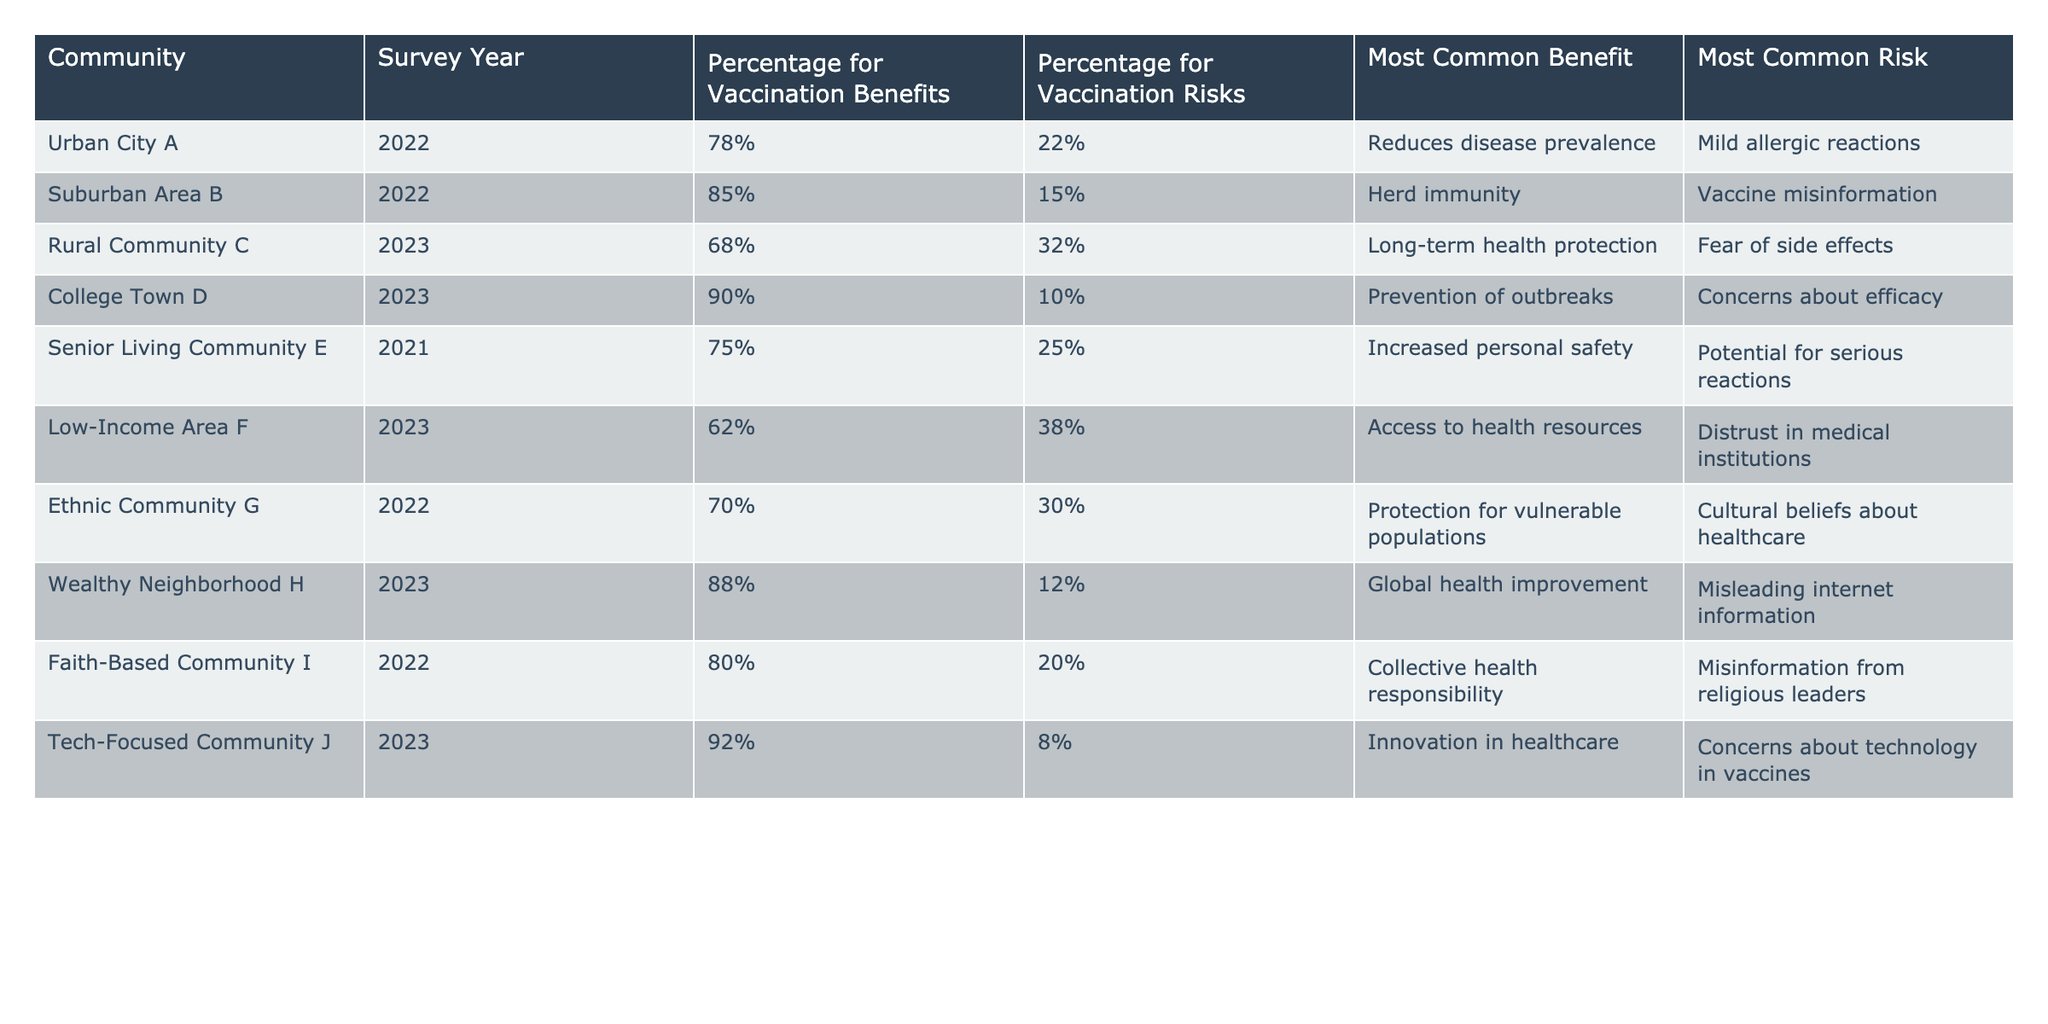What percentage of respondents in Rural Community C believe in vaccination benefits? Referring to the table, the percentage for vaccination benefits in Rural Community C is listed as 68%.
Answer: 68% Which community had the highest percentage of belief in vaccination benefits? The table shows that College Town D has the highest percentage for vaccination benefits at 90%.
Answer: 90% What is the most common risk mentioned by respondents in Low-Income Area F? According to the table, the most common risk in Low-Income Area F is "Distrust in medical institutions."
Answer: Distrust in medical institutions How many communities had a percentage for vaccination risks of 30% or above? Based on the table, the communities with 30% or above for vaccination risks are Rural Community C (32%), Low-Income Area F (38%), Ethnic Community G (30%), and Senior Living Community E (25%). This totals 4 communities.
Answer: 4 Is there a community where the most common benefit relates to healthcare innovation? The table shows that Tech-Focused Community J lists the most common benefit as "Innovation in healthcare." Therefore, the answer is yes.
Answer: Yes What is the average percentage of belief in vaccination benefits across all communities? The percentages are: 78, 85, 68, 90, 75, 62, 70, 88, 80, and 92. The sum is 828 and dividing by 10 gives an average of 82.8%.
Answer: 82.8% Which community has the least concern about vaccination risks? The percentage for vaccination risks is lowest in Tech-Focused Community J, which has only 8%.
Answer: 8% What common benefit is shared by both Suburban Area B and Wealthy Neighborhood H? Both Suburban Area B and Wealthy Neighborhood H list "Herd immunity" and "Global health improvement," respectively, which relate to improving overall community health, but no identical terms. The answer is no common benefit.
Answer: No common benefit Are respondents in Faith-Based Community I more concerned about misinformation from religious leaders or mild allergic reactions? The table indicates that the most common risk for Faith-Based Community I is "Misinformation from religious leaders," which implies this is viewed as a greater concern than mild allergic reactions stated elsewhere.
Answer: Misinformation from religious leaders What is the percentage difference in belief regarding vaccination benefits between College Town D and Low-Income Area F? College Town D has 90% for vaccination benefits while Low-Income Area F has 62%. The difference is 90% - 62% = 28%.
Answer: 28% 